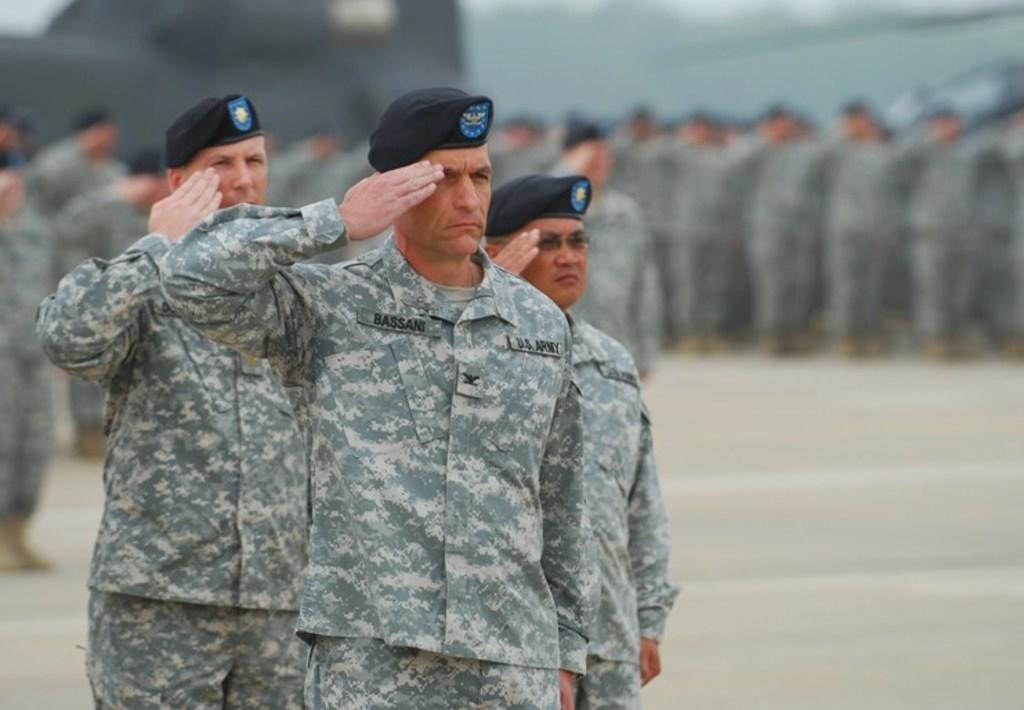What type of people are present in the image? There are army people in the image. What are the army people wearing on their heads? The army people are wearing caps. Where are the army people standing? The army people are standing on the ground. In which direction are the army people facing in the image? The provided facts do not specify the direction the army people are facing, so it cannot be determined from the image. 